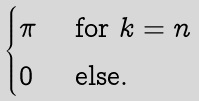<formula> <loc_0><loc_0><loc_500><loc_500>\begin{cases} \pi & \text { for } k = n \\ 0 & \text { else.} \end{cases}</formula> 